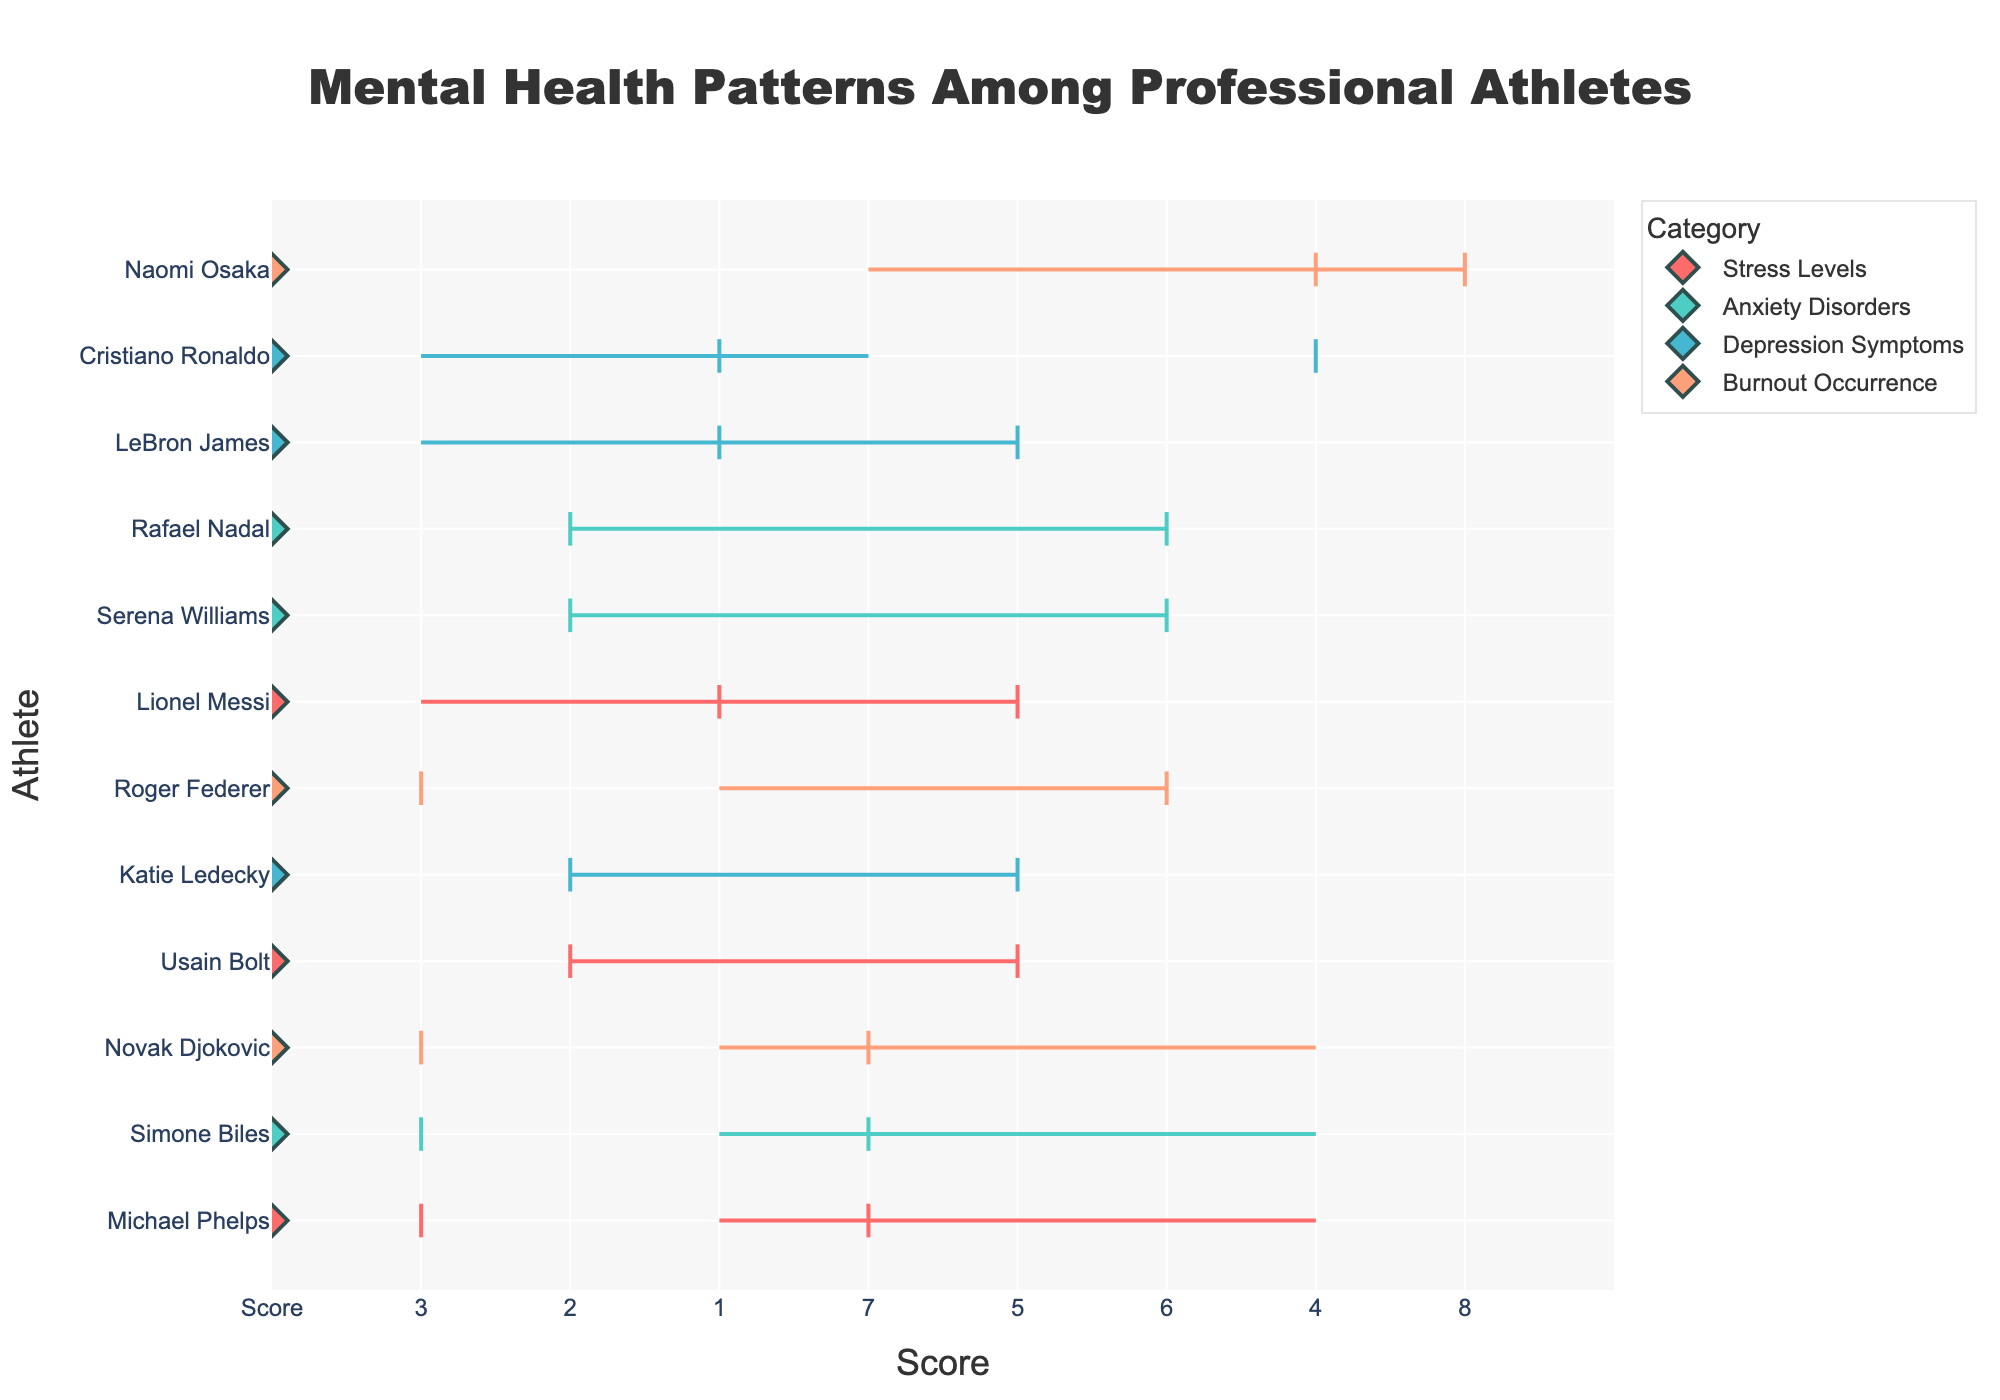what is the title of the figure? The title is usually located at the top center of the figure and describes the content or the focus of the plot. In this case, the title reads 'Mental Health Patterns Among Professional Athletes.'
Answer: Mental Health Patterns Among Professional Athletes Which athlete has the highest upper bound for stress levels? By comparing the upper bounds for stress levels, which include Michael Phelps, Usain Bolt, and Lionel Messi, Michael Phelps has the highest upper bound with a score of 7.
Answer: Michael Phelps What range does Naomi Osaka have for burnout occurrence? Naomi Osaka's range for burnout occurrence extends from the lower bound of 4 to the upper bound of 8, as seen in the figure.
Answer: 4-8 Between Serena Williams and Rafael Nadal, who has a higher lower bound for anxiety disorders? Serena Williams has a lower bound of 2, while Rafael Nadal also has a lower bound of 2 for anxiety disorders. So, they have equal lower bounds.
Answer: Equal What is the average of the upper bounds for depression symptoms among the athletes? The upper bounds for depression symptoms are 5 (LeBron James), 4 (Cristiano Ronaldo), and 5 (Katie Ledecky). The average is calculated as (5 + 4 + 5)/3 = 14/3 = 4.67.
Answer: 4.67 Which category has the widest range for any athlete? By examining the ranges across all categories, Naomi Osaka's burnout occurrence range is the widest, extending from 4 to 8, making a total range of 4.
Answer: Burnout Occurrence Who has a burnout occurrence range of 3-6? Roger Federer is the athlete with a burnout occurrence range extending from 3 to 6.
Answer: Roger Federer How many athletes have stress level metrics presented? By counting the athletes listed under the stress levels category, we find Michael Phelps, Usain Bolt, and Lionel Messi, totaling 3 athletes.
Answer: 3 Which athlete has the narrowest range for anxiety disorders? The ranges for anxiety disorders among the athletes are Serena Williams (2-6), Simone Biles (3-7), and Rafael Nadal (2-6). Both Serena Williams and Rafael Nadal share the narrowest range of 4.
Answer: Serena Williams and Rafael Nadal Is there any athlete with an equal range for all metrics? By checking the ranges for each category, the ranges for stress levels, anxiety disorders, depression symptoms, and burnout occurrence are all different. No athlete has an equal range across all metrics.
Answer: No 